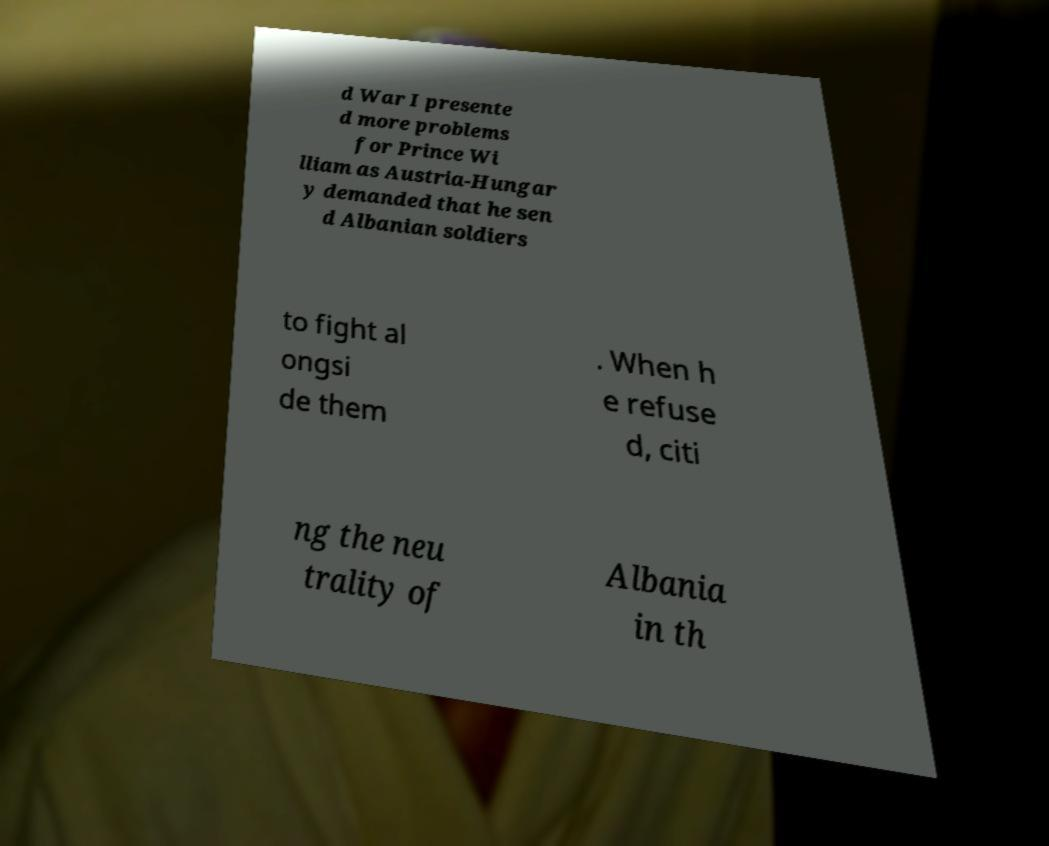There's text embedded in this image that I need extracted. Can you transcribe it verbatim? d War I presente d more problems for Prince Wi lliam as Austria-Hungar y demanded that he sen d Albanian soldiers to fight al ongsi de them . When h e refuse d, citi ng the neu trality of Albania in th 